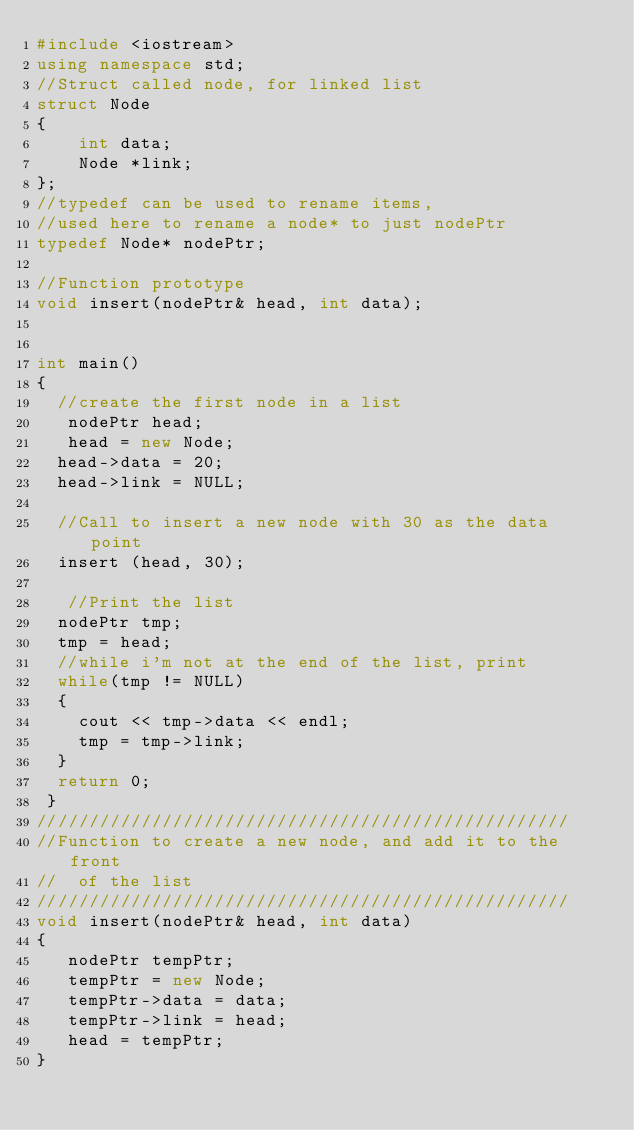Convert code to text. <code><loc_0><loc_0><loc_500><loc_500><_C++_>#include <iostream> 
using namespace std; 
//Struct called node, for linked list
struct Node
{
    int data;
    Node *link;
};
//typedef can be used to rename items,
//used here to rename a node* to just nodePtr
typedef Node* nodePtr;

//Function prototype
void insert(nodePtr& head, int data);


int main()
{
	//create the first node in a list
   nodePtr head;
   head = new Node;
 	head->data = 20;
 	head->link = NULL;

 	//Call to insert a new node with 30 as the data point
 	insert (head, 30);
 	
	 //Print the list
	nodePtr tmp;
 	tmp = head;
 	//while i'm not at the end of the list, print
 	while(tmp != NULL)
	{
		cout << tmp->data << endl;
		tmp = tmp->link;
	}
  return 0;
 }
///////////////////////////////////////////////////
//Function to create a new node, and add it to the front
//  of the list
///////////////////////////////////////////////////
void insert(nodePtr& head, int data)
{
   nodePtr tempPtr;
   tempPtr = new Node;
   tempPtr->data = data;
   tempPtr->link = head;
   head = tempPtr;
}

</code> 